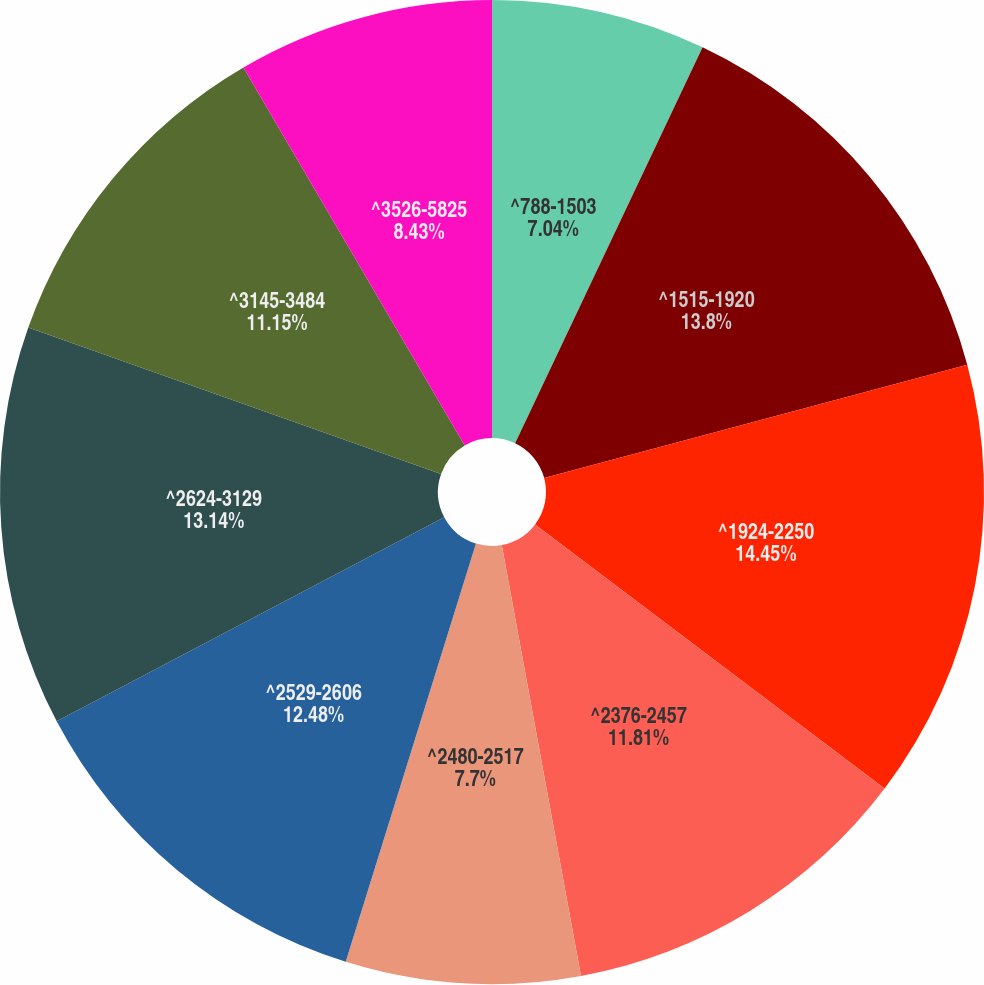Convert chart. <chart><loc_0><loc_0><loc_500><loc_500><pie_chart><fcel>^788-1503<fcel>^1515-1920<fcel>^1924-2250<fcel>^2376-2457<fcel>^2480-2517<fcel>^2529-2606<fcel>^2624-3129<fcel>^3145-3484<fcel>^3526-5825<nl><fcel>7.04%<fcel>13.8%<fcel>14.46%<fcel>11.81%<fcel>7.7%<fcel>12.48%<fcel>13.14%<fcel>11.15%<fcel>8.43%<nl></chart> 